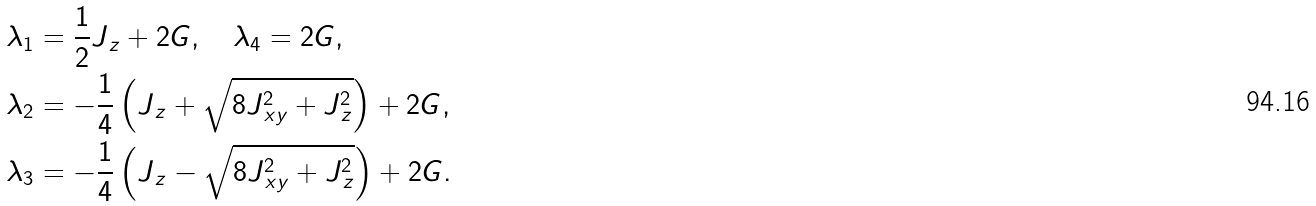<formula> <loc_0><loc_0><loc_500><loc_500>\lambda _ { 1 } & = \frac { 1 } { 2 } J _ { \, z } + 2 G , \quad \lambda _ { 4 } = 2 G , \\ \lambda _ { 2 } & = - \frac { 1 } { 4 } \left ( J _ { \, z } + \sqrt { 8 J _ { \, x y } ^ { 2 } + J _ { \, z } ^ { 2 } } \right ) + 2 G , \\ \lambda _ { 3 } & = - \frac { 1 } { 4 } \left ( J _ { \, z } - \sqrt { 8 J _ { \, x y } ^ { 2 } + J _ { \, z } ^ { 2 } } \right ) + 2 G .</formula> 